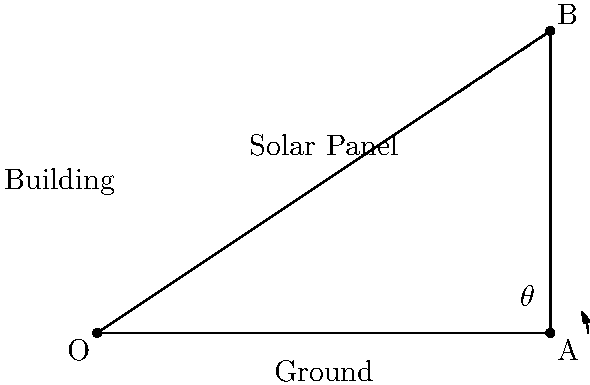As a treasury officer, you're tasked with optimizing energy savings for government buildings. A proposal suggests installing solar panels on a building's roof. The building is 4 meters tall, and the solar panel needs to extend 6 meters from the base. At what angle $\theta$ (in degrees) should the solar panel be positioned to maximize energy capture, assuming the optimal angle is perpendicular to the sun's rays at noon? To solve this problem, we'll use trigonometry:

1) We have a right triangle with the following dimensions:
   - Base (adjacent to angle $\theta$) = 6 meters
   - Height (opposite to angle $\theta$) = 4 meters

2) To find the angle $\theta$, we can use the tangent function:

   $\tan(\theta) = \frac{\text{opposite}}{\text{adjacent}} = \frac{4}{6} = \frac{2}{3}$

3) To get $\theta$, we need to use the inverse tangent (arctan or $\tan^{-1}$):

   $\theta = \tan^{-1}(\frac{2}{3})$

4) Using a calculator or trigonometric tables:

   $\theta \approx 33.69$ degrees

5) Round to the nearest degree:

   $\theta \approx 34$ degrees

This angle will position the solar panel perpendicular to the sun's rays at noon, maximizing energy capture and potentially leading to significant energy savings for the government building.
Answer: 34° 